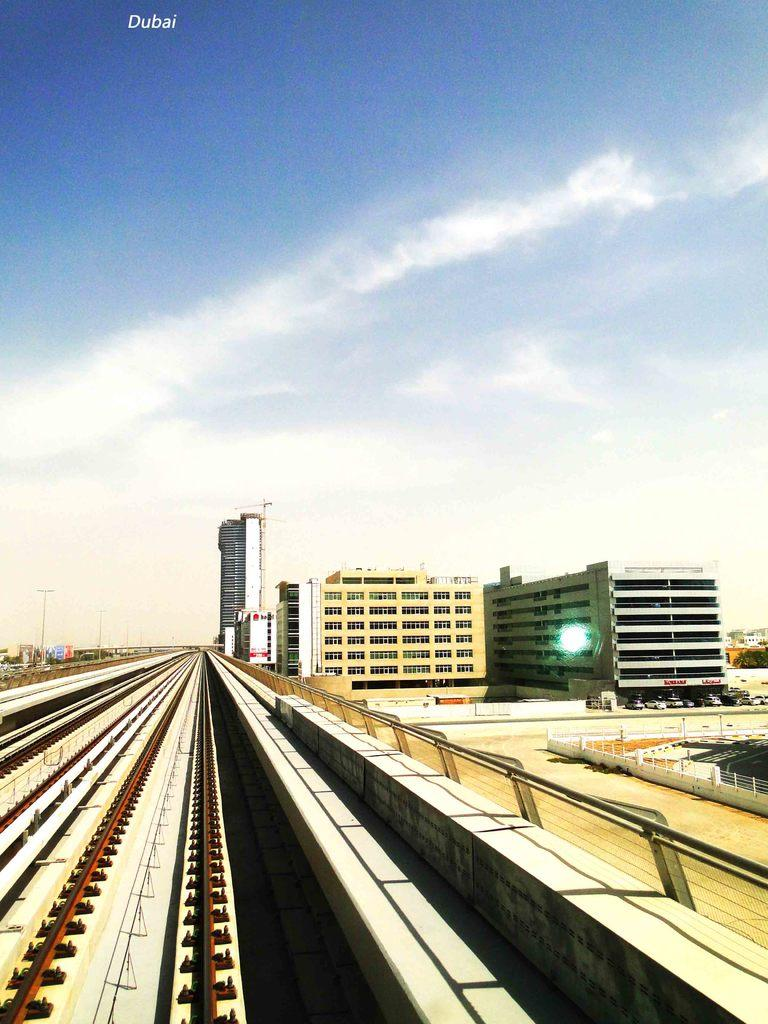What is the main feature in the center of the image? There are railway tracks in the center of the image. What can be seen on the right side of the image? There are buildings and roads on the right side of the image. What is visible in the background of the image? The sky is visible in the background of the image. What type of weather can be inferred from the background? Clouds are present in the background of the image, suggesting a partly cloudy day. What type of jam is being spread on the boot in the image? There is no jam or boot present in the image; it features railway tracks, buildings, roads, sky, and clouds. 